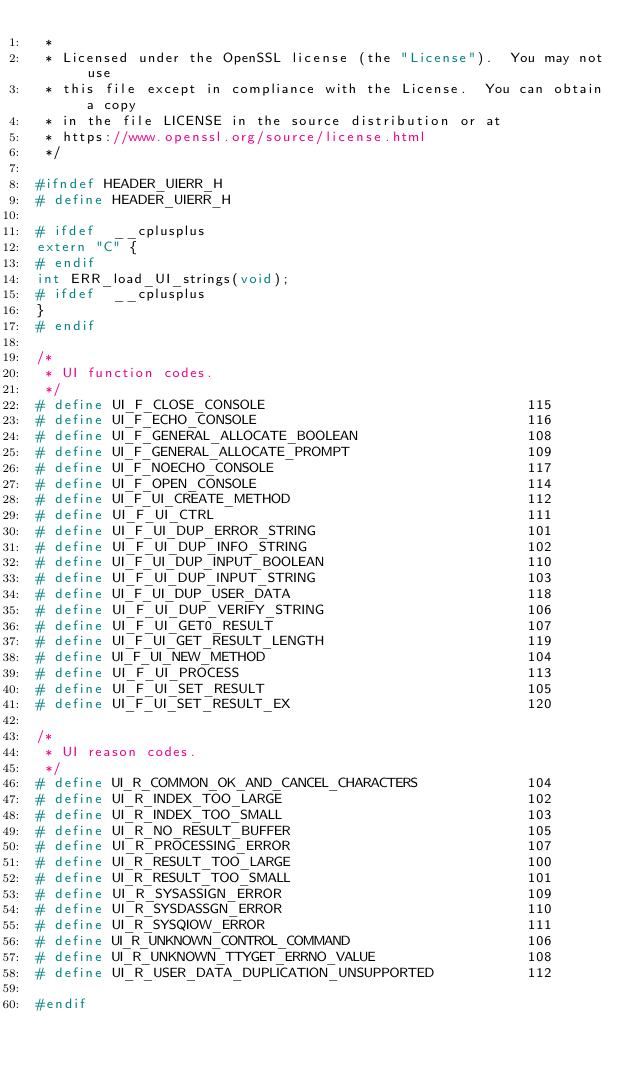<code> <loc_0><loc_0><loc_500><loc_500><_C_> *
 * Licensed under the OpenSSL license (the "License").  You may not use
 * this file except in compliance with the License.  You can obtain a copy
 * in the file LICENSE in the source distribution or at
 * https://www.openssl.org/source/license.html
 */

#ifndef HEADER_UIERR_H
# define HEADER_UIERR_H

# ifdef  __cplusplus
extern "C" {
# endif
int ERR_load_UI_strings(void);
# ifdef  __cplusplus
}
# endif

/*
 * UI function codes.
 */
# define UI_F_CLOSE_CONSOLE                               115
# define UI_F_ECHO_CONSOLE                                116
# define UI_F_GENERAL_ALLOCATE_BOOLEAN                    108
# define UI_F_GENERAL_ALLOCATE_PROMPT                     109
# define UI_F_NOECHO_CONSOLE                              117
# define UI_F_OPEN_CONSOLE                                114
# define UI_F_UI_CREATE_METHOD                            112
# define UI_F_UI_CTRL                                     111
# define UI_F_UI_DUP_ERROR_STRING                         101
# define UI_F_UI_DUP_INFO_STRING                          102
# define UI_F_UI_DUP_INPUT_BOOLEAN                        110
# define UI_F_UI_DUP_INPUT_STRING                         103
# define UI_F_UI_DUP_USER_DATA                            118
# define UI_F_UI_DUP_VERIFY_STRING                        106
# define UI_F_UI_GET0_RESULT                              107
# define UI_F_UI_GET_RESULT_LENGTH                        119
# define UI_F_UI_NEW_METHOD                               104
# define UI_F_UI_PROCESS                                  113
# define UI_F_UI_SET_RESULT                               105
# define UI_F_UI_SET_RESULT_EX                            120

/*
 * UI reason codes.
 */
# define UI_R_COMMON_OK_AND_CANCEL_CHARACTERS             104
# define UI_R_INDEX_TOO_LARGE                             102
# define UI_R_INDEX_TOO_SMALL                             103
# define UI_R_NO_RESULT_BUFFER                            105
# define UI_R_PROCESSING_ERROR                            107
# define UI_R_RESULT_TOO_LARGE                            100
# define UI_R_RESULT_TOO_SMALL                            101
# define UI_R_SYSASSIGN_ERROR                             109
# define UI_R_SYSDASSGN_ERROR                             110
# define UI_R_SYSQIOW_ERROR                               111
# define UI_R_UNKNOWN_CONTROL_COMMAND                     106
# define UI_R_UNKNOWN_TTYGET_ERRNO_VALUE                  108
# define UI_R_USER_DATA_DUPLICATION_UNSUPPORTED           112

#endif
</code> 